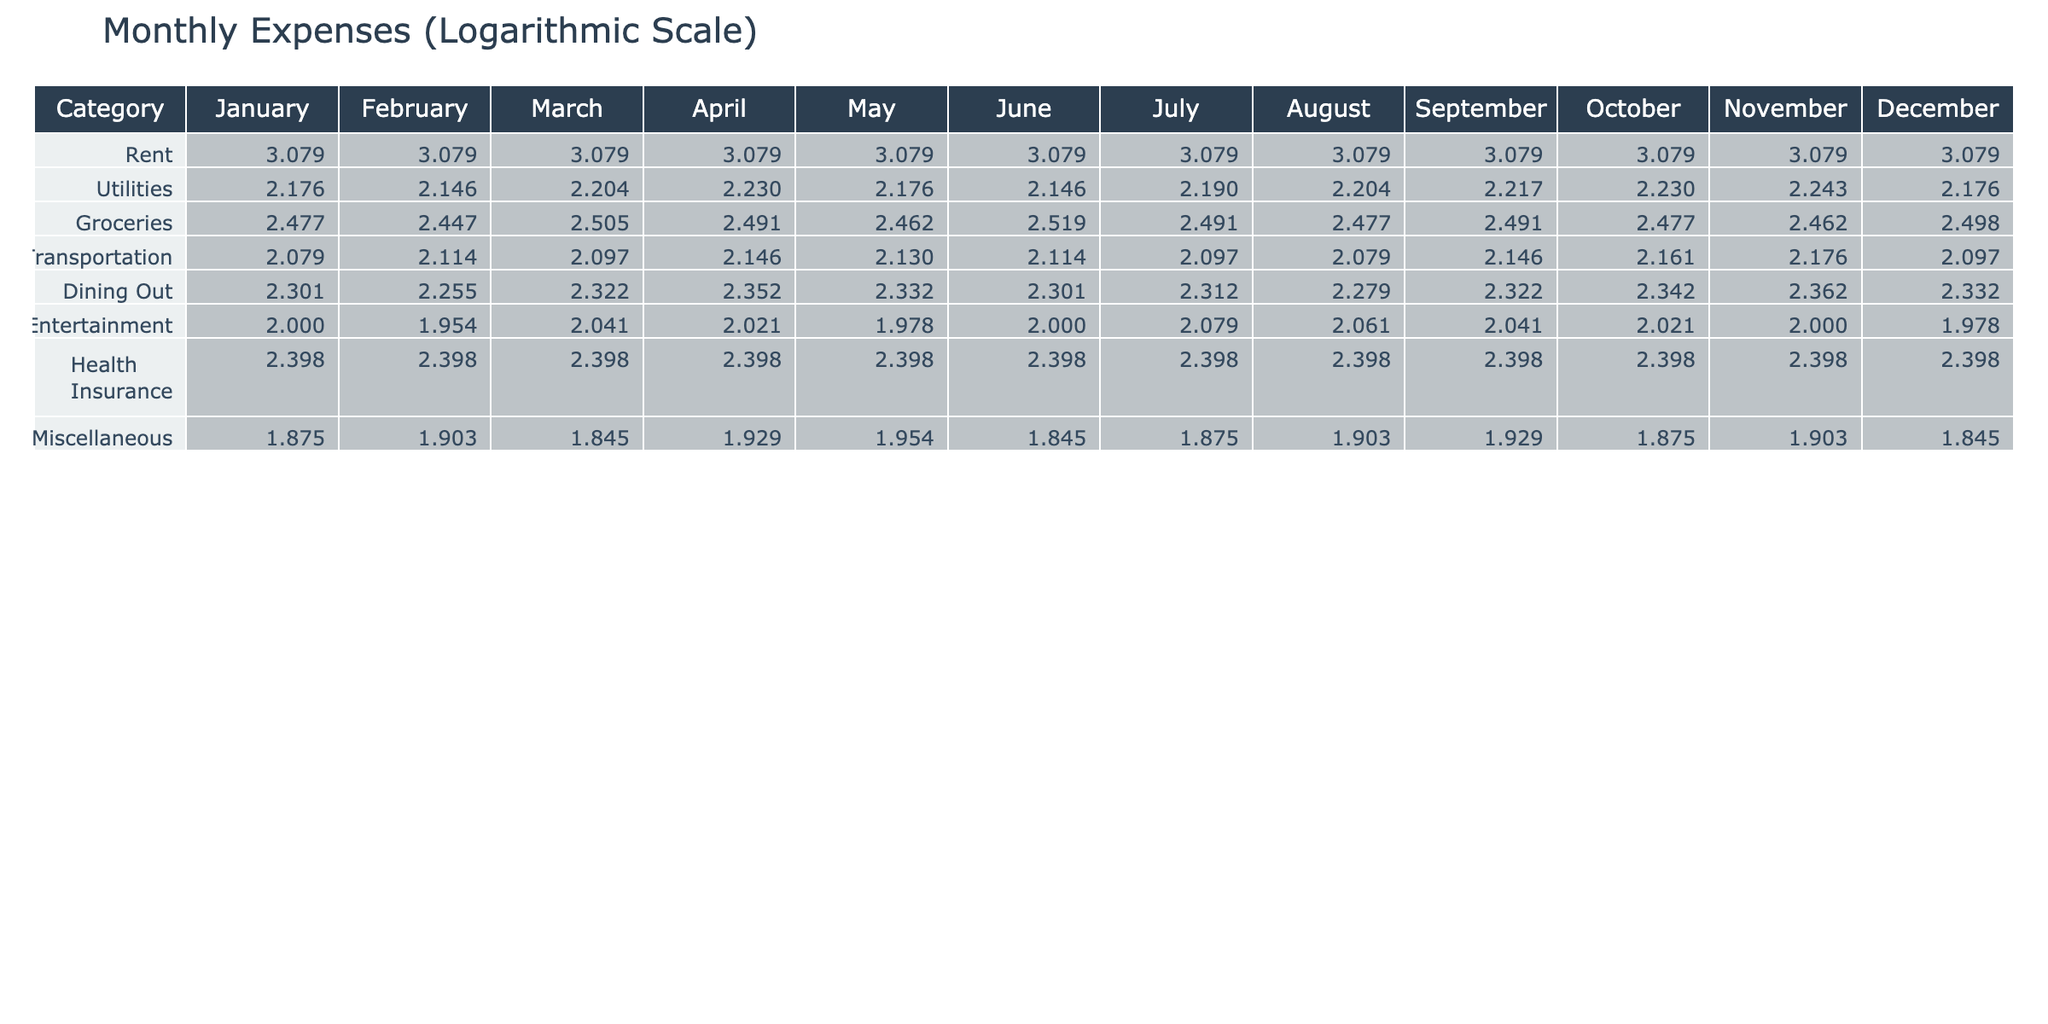What was the highest monthly expense in December? By looking at the December row for each category, the highest expense value is in the Rent category, which is 1200 (on a logarithmic scale it's log10(1200)).
Answer: 1200 What were the total expenses for Groceries from January to March? The expenses for Groceries in January, February, and March are 300, 280, and 320 respectively. Adding these values gives 300 + 280 + 320 = 900.
Answer: 900 Is the average expense for Utilities greater than or equal to 160? To find the average, we first sum the Utility expenses from all months: 150 + 140 + 160 + 170 + 150 + 140 + 155 + 160 + 165 + 170 + 175 + 150 = 1,320. There are 12 months, so the average is 1,320 / 12 = 110. Yes, the average is less than 160.
Answer: No Which month had the lowest Transportation expense? Looking at the Transportation expenses for each month, the values are 120, 130, 125, 140, 135, 130, 125, 120, 140, 145, 150, and 125. The lowest value is in January at 120.
Answer: January What was the percentage change in Dining Out expenses from January to December? The January Dining Out expense is 200 and December's expense is 215. The change is 215 - 200 = 15. The percentage change is (15 / 200) * 100 = 7.5%.
Answer: 7.5% What is the sum of the Miscellaneous expenses for the entire year? The Miscellaneous expenses for each month are 75, 80, 70, 85, 90, 70, 75, 80, 85, 75, 80, and 70. Adding these values gives 75 + 80 + 70 + 85 + 90 + 70 + 75 + 80 + 85 + 75 + 80 + 70 = 1,015.
Answer: 1015 Did the Groceries expenses ever exceed 350 in any month? The expenses for Groceries each month are 300, 280, 320, 310, 290, 330, 310, 300, 310, 300, 290, and 315. By comparing these values with 350, none exceed this amount.
Answer: No In which month did the Utilities expenses have the highest value? Examining the Utilities expenses across all months reveals the highest value is 175, which occurred in November.
Answer: November 